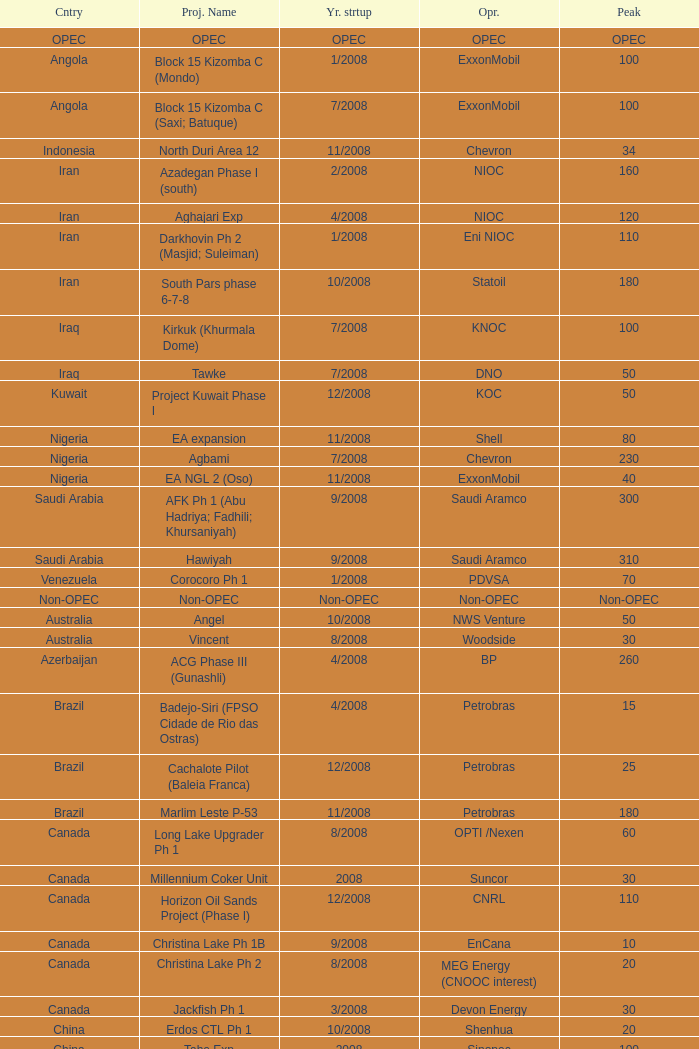Could you help me parse every detail presented in this table? {'header': ['Cntry', 'Proj. Name', 'Yr. strtup', 'Opr.', 'Peak'], 'rows': [['OPEC', 'OPEC', 'OPEC', 'OPEC', 'OPEC'], ['Angola', 'Block 15 Kizomba C (Mondo)', '1/2008', 'ExxonMobil', '100'], ['Angola', 'Block 15 Kizomba C (Saxi; Batuque)', '7/2008', 'ExxonMobil', '100'], ['Indonesia', 'North Duri Area 12', '11/2008', 'Chevron', '34'], ['Iran', 'Azadegan Phase I (south)', '2/2008', 'NIOC', '160'], ['Iran', 'Aghajari Exp', '4/2008', 'NIOC', '120'], ['Iran', 'Darkhovin Ph 2 (Masjid; Suleiman)', '1/2008', 'Eni NIOC', '110'], ['Iran', 'South Pars phase 6-7-8', '10/2008', 'Statoil', '180'], ['Iraq', 'Kirkuk (Khurmala Dome)', '7/2008', 'KNOC', '100'], ['Iraq', 'Tawke', '7/2008', 'DNO', '50'], ['Kuwait', 'Project Kuwait Phase I', '12/2008', 'KOC', '50'], ['Nigeria', 'EA expansion', '11/2008', 'Shell', '80'], ['Nigeria', 'Agbami', '7/2008', 'Chevron', '230'], ['Nigeria', 'EA NGL 2 (Oso)', '11/2008', 'ExxonMobil', '40'], ['Saudi Arabia', 'AFK Ph 1 (Abu Hadriya; Fadhili; Khursaniyah)', '9/2008', 'Saudi Aramco', '300'], ['Saudi Arabia', 'Hawiyah', '9/2008', 'Saudi Aramco', '310'], ['Venezuela', 'Corocoro Ph 1', '1/2008', 'PDVSA', '70'], ['Non-OPEC', 'Non-OPEC', 'Non-OPEC', 'Non-OPEC', 'Non-OPEC'], ['Australia', 'Angel', '10/2008', 'NWS Venture', '50'], ['Australia', 'Vincent', '8/2008', 'Woodside', '30'], ['Azerbaijan', 'ACG Phase III (Gunashli)', '4/2008', 'BP', '260'], ['Brazil', 'Badejo-Siri (FPSO Cidade de Rio das Ostras)', '4/2008', 'Petrobras', '15'], ['Brazil', 'Cachalote Pilot (Baleia Franca)', '12/2008', 'Petrobras', '25'], ['Brazil', 'Marlim Leste P-53', '11/2008', 'Petrobras', '180'], ['Canada', 'Long Lake Upgrader Ph 1', '8/2008', 'OPTI /Nexen', '60'], ['Canada', 'Millennium Coker Unit', '2008', 'Suncor', '30'], ['Canada', 'Horizon Oil Sands Project (Phase I)', '12/2008', 'CNRL', '110'], ['Canada', 'Christina Lake Ph 1B', '9/2008', 'EnCana', '10'], ['Canada', 'Christina Lake Ph 2', '8/2008', 'MEG Energy (CNOOC interest)', '20'], ['Canada', 'Jackfish Ph 1', '3/2008', 'Devon Energy', '30'], ['China', 'Erdos CTL Ph 1', '10/2008', 'Shenhua', '20'], ['China', 'Tahe Exp', '2008', 'Sinopec', '100'], ['China', 'Wenchang Exp', '7/2008', 'CNOOC', '40'], ['China', 'Xijiang 23-1', '6/2008', 'CNOOC', '40'], ['Congo', 'Moho Bilondo', '4/2008', 'Total', '90'], ['Egypt', 'Saqqara', '3/2008', 'BP', '40'], ['India', 'MA field (KG-D6)', '9/2008', 'Reliance', '40'], ['Kazakhstan', 'Dunga', '3/2008', 'Maersk', '150'], ['Kazakhstan', 'Komsomolskoe', '5/2008', 'Petrom', '10'], ['Mexico', '( Chicontepec ) Exp 1', '2008', 'PEMEX', '200'], ['Mexico', 'Antonio J Bermudez Exp', '5/2008', 'PEMEX', '20'], ['Mexico', 'Bellota Chinchorro Exp', '5/2008', 'PEMEX', '20'], ['Mexico', 'Ixtal Manik', '2008', 'PEMEX', '55'], ['Mexico', 'Jujo Tecominoacan Exp', '2008', 'PEMEX', '15'], ['Norway', 'Alvheim; Volund; Vilje', '6/2008', 'Marathon', '100'], ['Norway', 'Volve', '2/2008', 'StatoilHydro', '35'], ['Oman', 'Mukhaizna EOR Ph 1', '2008', 'Occidental', '40'], ['Philippines', 'Galoc', '10/2008', 'GPC', '15'], ['Russia', 'Talakan Ph 1', '10/2008', 'Surgutneftegaz', '60'], ['Russia', 'Verkhnechonsk Ph 1 (early oil)', '10/2008', 'TNK-BP Rosneft', '20'], ['Russia', 'Yuzhno-Khylchuyuskoye "YK" Ph 1', '8/2008', 'Lukoil ConocoPhillips', '75'], ['Thailand', 'Bualuang', '8/2008', 'Salamander', '10'], ['UK', 'Britannia Satellites (Callanish; Brodgar)', '7/2008', 'Conoco Phillips', '25'], ['USA', 'Blind Faith', '11/2008', 'Chevron', '45'], ['USA', 'Neptune', '7/2008', 'BHP Billiton', '25'], ['USA', 'Oooguruk', '6/2008', 'Pioneer', '15'], ['USA', 'Qannik', '7/2008', 'ConocoPhillips', '4'], ['USA', 'Thunder Horse', '6/2008', 'BP', '210'], ['USA', 'Ursa Princess Exp', '1/2008', 'Shell', '30'], ['Vietnam', 'Ca Ngu Vang (Golden Tuna)', '7/2008', 'HVJOC', '15'], ['Vietnam', 'Su Tu Vang', '10/2008', 'Cuu Long Joint', '40'], ['Vietnam', 'Song Doc', '12/2008', 'Talisman', '10']]} What is the Peak with a Project Name that is talakan ph 1? 60.0. 